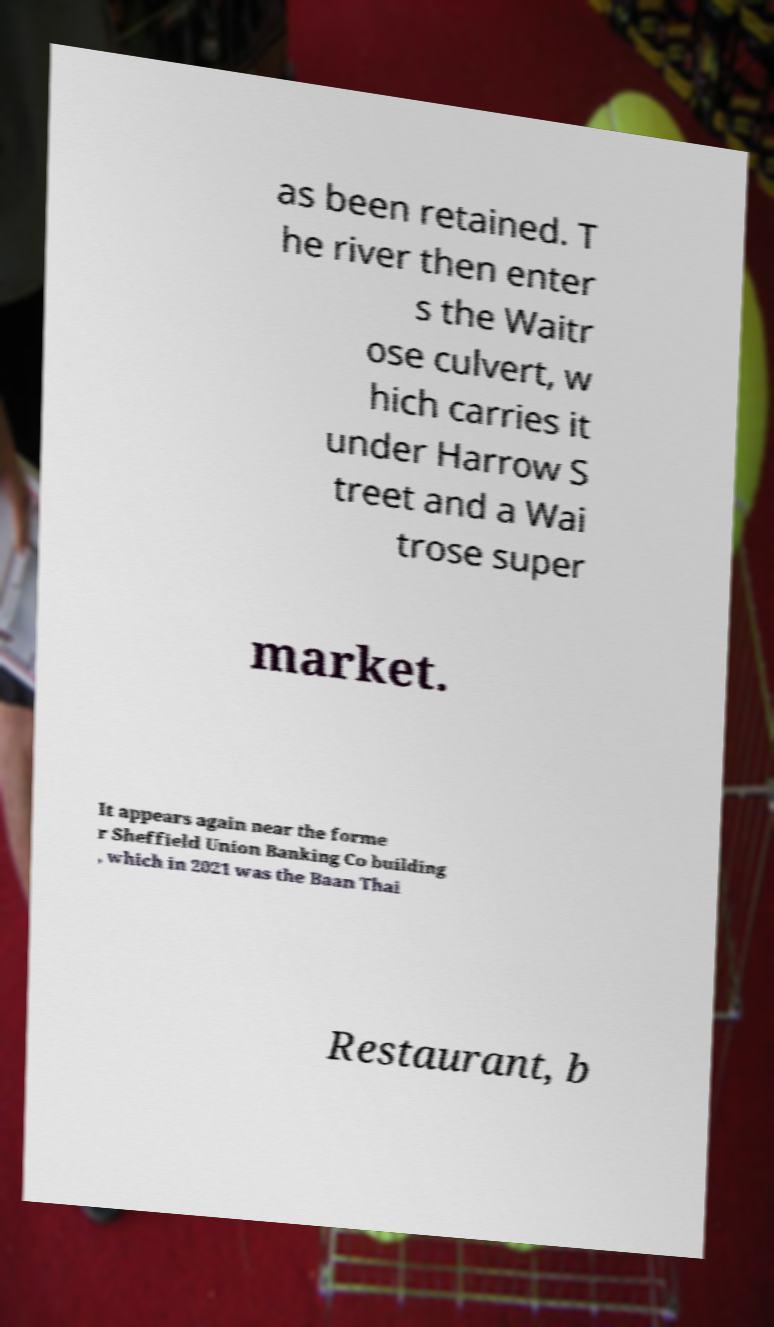I need the written content from this picture converted into text. Can you do that? as been retained. T he river then enter s the Waitr ose culvert, w hich carries it under Harrow S treet and a Wai trose super market. It appears again near the forme r Sheffield Union Banking Co building , which in 2021 was the Baan Thai Restaurant, b 